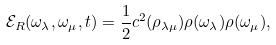<formula> <loc_0><loc_0><loc_500><loc_500>\mathcal { E } _ { R } ( \omega _ { \lambda } , \omega _ { \mu } , t ) = \frac { 1 } { 2 } c ^ { 2 } ( \rho _ { \lambda \mu } ) \rho ( \omega _ { \lambda } ) \rho ( \omega _ { \mu } ) ,</formula> 